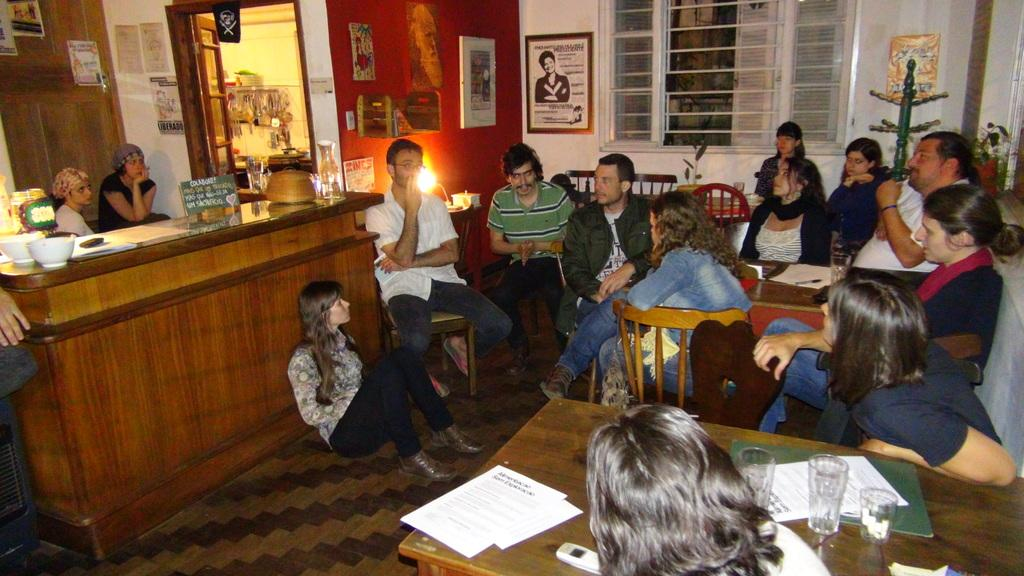What are the people in the image doing? The people in the image are sitting on chairs. What objects can be seen on the table in the image? There are glasses and papers on the table in the image. What can be seen on the walls in the background of the image? There are frames on the walls in the background of the image. What type of finger can be seen in the image? There are no fingers visible in the image. What kind of waste is being disposed of in the image? There is no waste being disposed of in the image. 